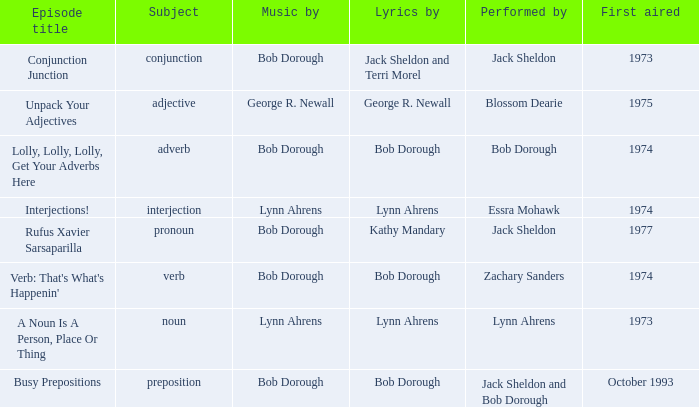When zachary sanders is the performer how many first aired are there? 1.0. 